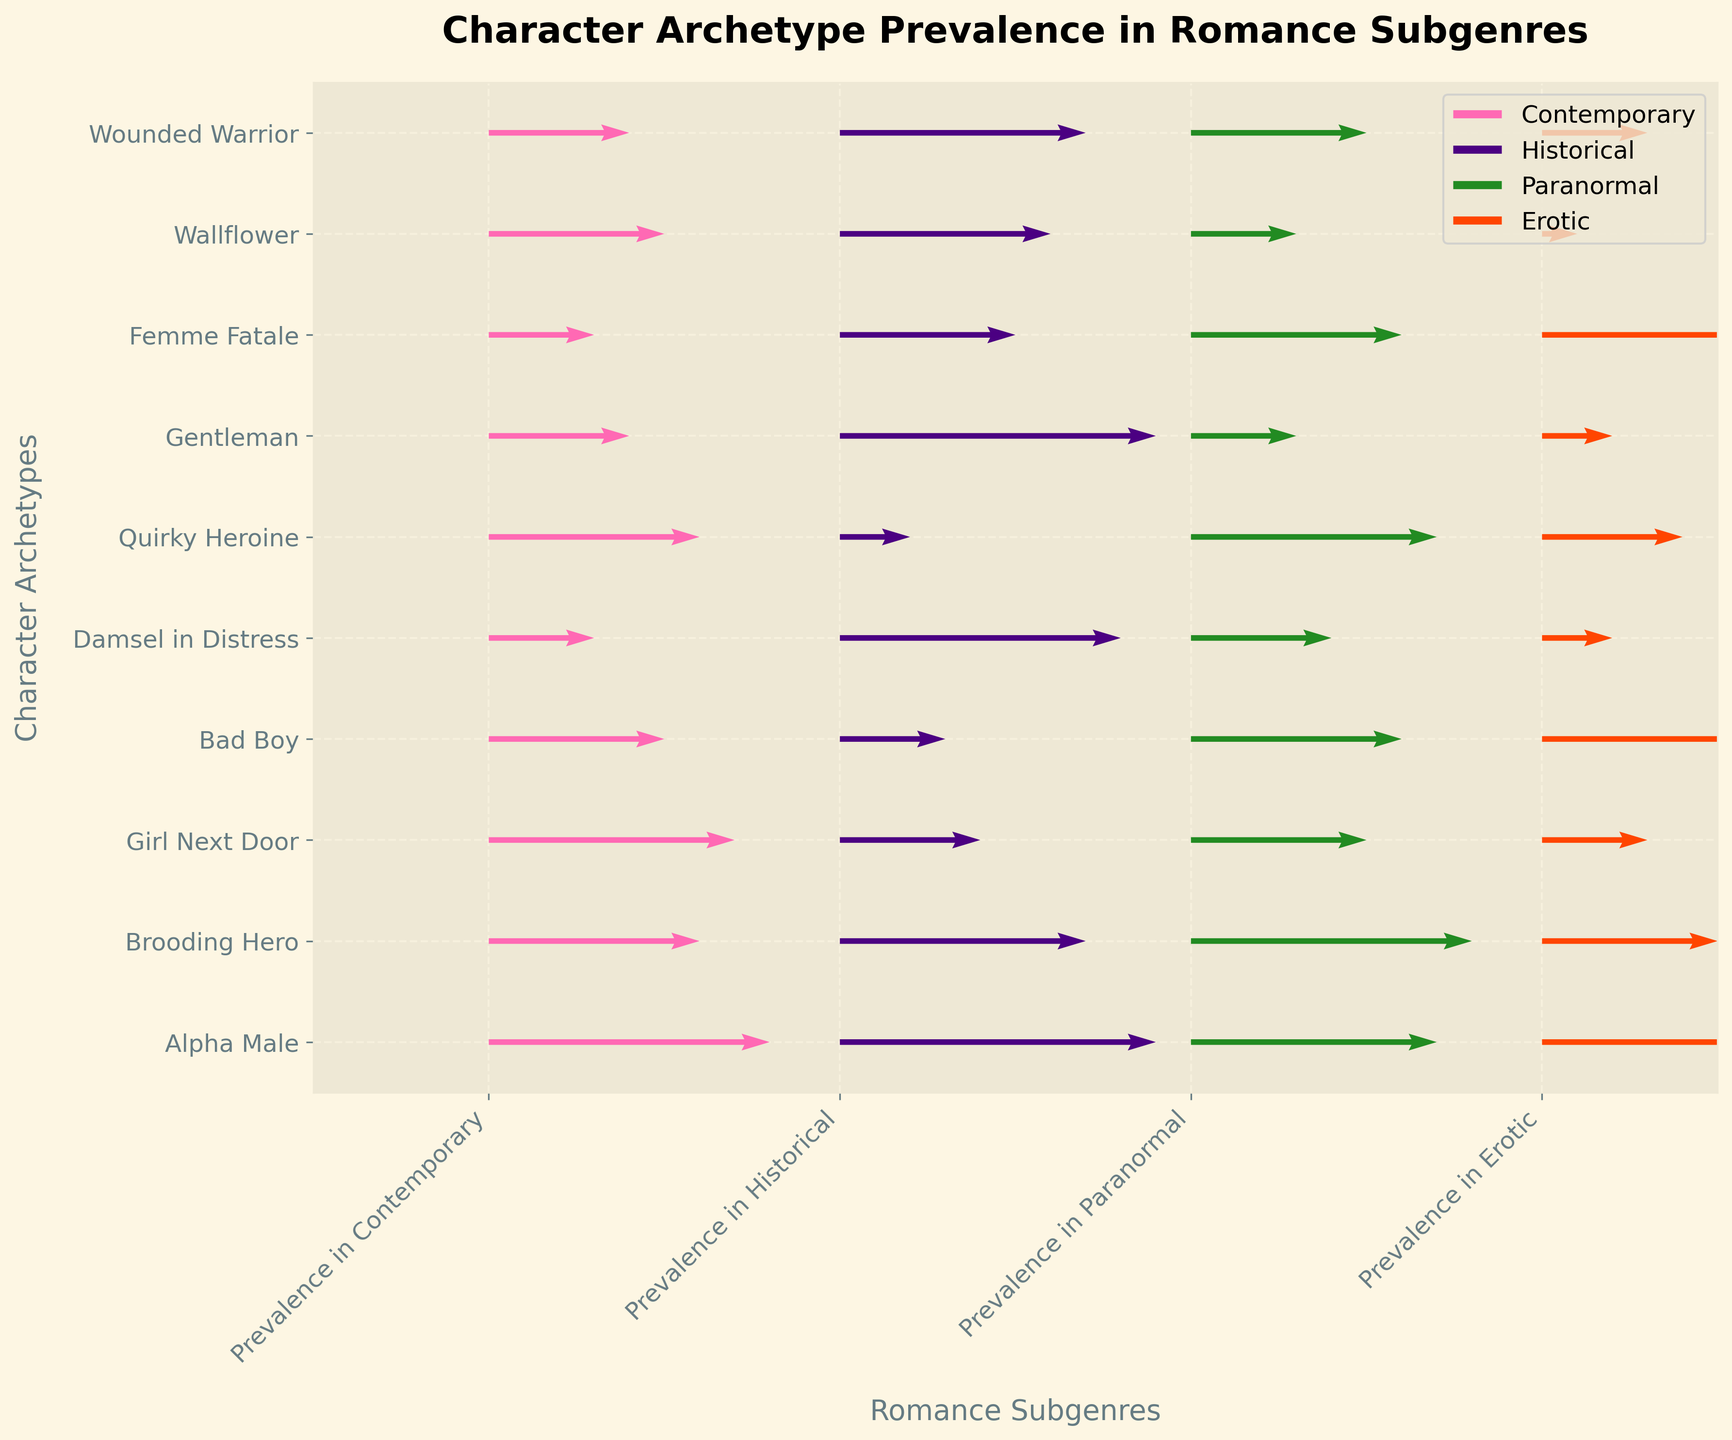What is the title of the figure? The title is usually placed at the top of the figure and is prominently displayed in bold text to quickly inform the viewer of the topic.
Answer: Character Archetype Prevalence in Romance Subgenres Which romance subgenre has the highest prevalence of the 'Alpha Male' archetype? Find 'Alpha Male' on the y-axis, then locate the longest arrow associated with it, which indicates the highest value among the subgenres.
Answer: Historical What is the difference in prevalence between the 'Brooding Hero' and 'Alpha Male' in the Paranormal subgenre? Find both 'Brooding Hero' and 'Alpha Male' on the y-axis, check their vectors for the Paranormal subgenre, and subtract the 'Alpha Male' value (0.7) from the 'Brooding Hero' value (0.8).
Answer: 0.1 Which character archetype is least prevalent in the Erotic subgenre? On the x-axis, locate 'Erotic' and find the archetype that has the shortest arrow (indicating the lowest prevalence) on the corresponding column.
Answer: Wallflower Which subgenre has a greater prevalence of the 'Bad Boy' archetype, Contemporary or Historical? Locate the 'Bad Boy' on the y-axis and compare the lengths of the arrows for Contemporary and Historical subgenres.
Answer: Contemporary What's the most prevalent character archetype in the Historical romance subgenre? Find 'Historical' on the x-axis and identify the longest arrow within this category.
Answer: Alpha Male Is the prevalence of 'Gentleman' higher in Historical or Erotic subgenres? Compare the 'Gentleman' arrows for both Historical and Erotic subgenres to see which one is longer.
Answer: Historical How does the prevalence of the 'Girl Next Door' in Contemporary compare to that in Historical? Look at the 'Girl Next Door' character on the y-axis and compare the lengths of the arrows for Contemporary and Historical subgenres.
Answer: Higher in Contemporary Which subgenre shows a closer prevalence between 'Quirky Heroine' and 'Femme Fatale'? Compare the arrow lengths for 'Quirky Heroine' and 'Femme Fatale' across all subgenres to find the one where they are closest in length to each other.
Answer: Paranormal What is common about the prevalence of the 'Damsel in Distress' and 'Wallflower' in the Historical subgenre? Identify the positions on the y-axis for 'Damsel in Distress' and 'Wallflower', then observe and compare their arrow lengths within the Historical subgenre.
Answer: Both are relatively high 